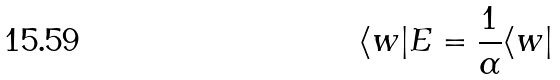Convert formula to latex. <formula><loc_0><loc_0><loc_500><loc_500>\langle w | E = \frac { 1 } { \alpha } \langle w |</formula> 